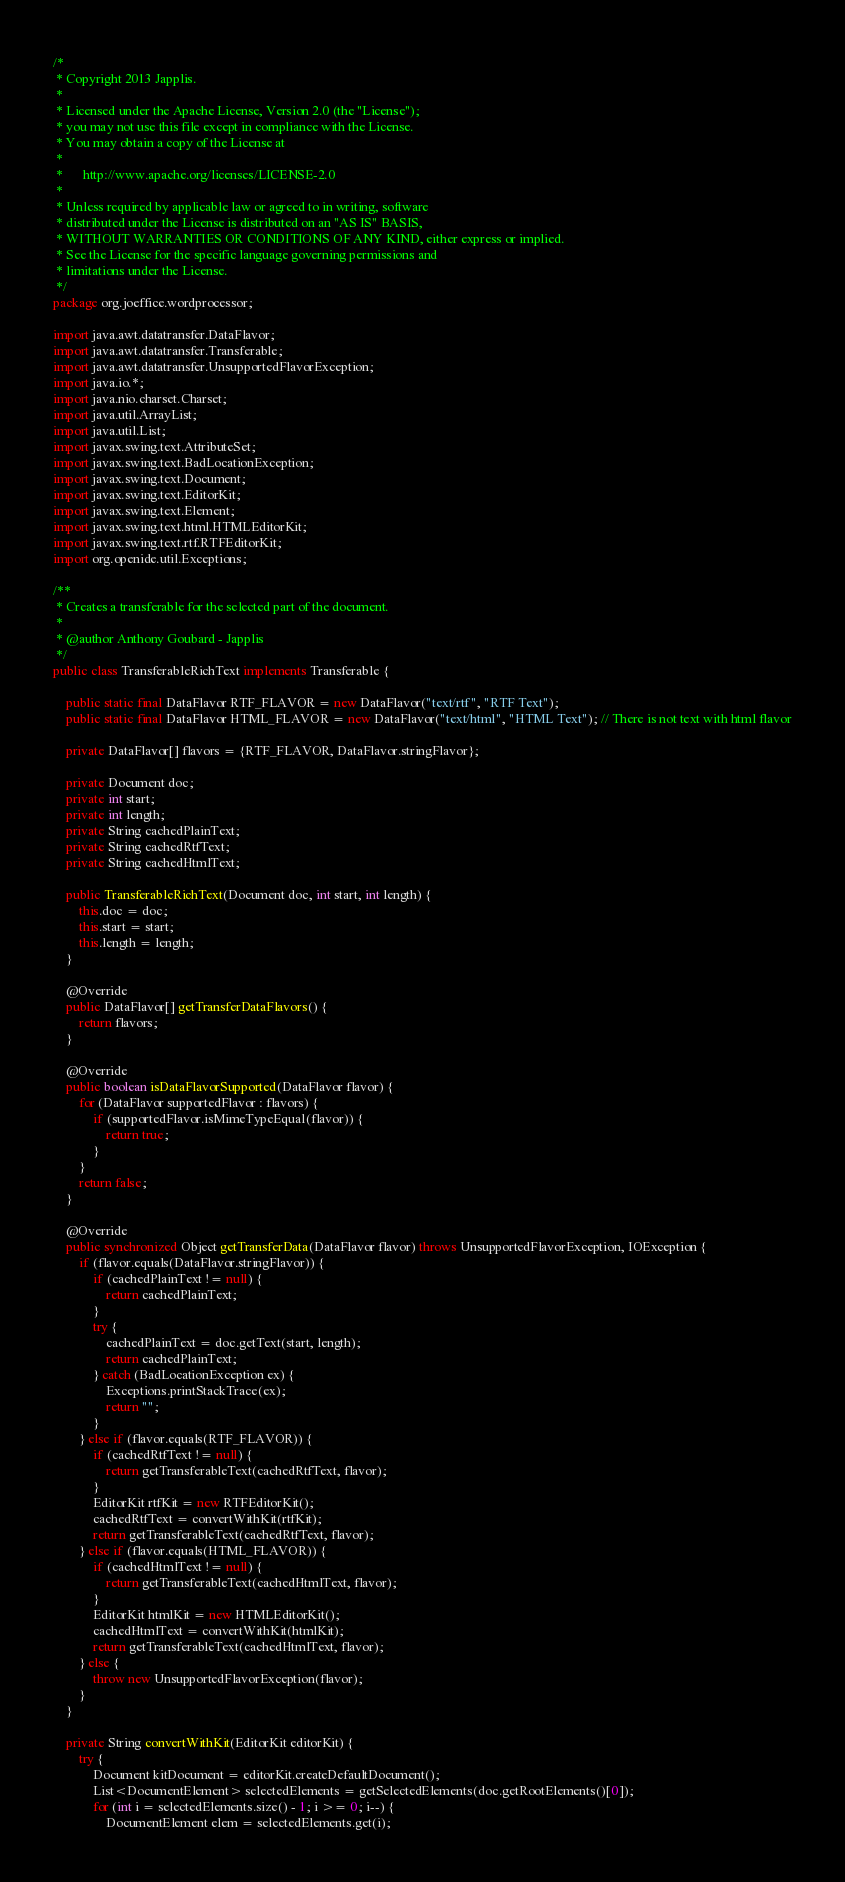Convert code to text. <code><loc_0><loc_0><loc_500><loc_500><_Java_>/*
 * Copyright 2013 Japplis.
 *
 * Licensed under the Apache License, Version 2.0 (the "License");
 * you may not use this file except in compliance with the License.
 * You may obtain a copy of the License at
 *
 *      http://www.apache.org/licenses/LICENSE-2.0
 *
 * Unless required by applicable law or agreed to in writing, software
 * distributed under the License is distributed on an "AS IS" BASIS,
 * WITHOUT WARRANTIES OR CONDITIONS OF ANY KIND, either express or implied.
 * See the License for the specific language governing permissions and
 * limitations under the License.
 */
package org.joeffice.wordprocessor;

import java.awt.datatransfer.DataFlavor;
import java.awt.datatransfer.Transferable;
import java.awt.datatransfer.UnsupportedFlavorException;
import java.io.*;
import java.nio.charset.Charset;
import java.util.ArrayList;
import java.util.List;
import javax.swing.text.AttributeSet;
import javax.swing.text.BadLocationException;
import javax.swing.text.Document;
import javax.swing.text.EditorKit;
import javax.swing.text.Element;
import javax.swing.text.html.HTMLEditorKit;
import javax.swing.text.rtf.RTFEditorKit;
import org.openide.util.Exceptions;

/**
 * Creates a transferable for the selected part of the document.
 *
 * @author Anthony Goubard - Japplis
 */
public class TransferableRichText implements Transferable {

    public static final DataFlavor RTF_FLAVOR = new DataFlavor("text/rtf", "RTF Text");
    public static final DataFlavor HTML_FLAVOR = new DataFlavor("text/html", "HTML Text"); // There is not text with html flavor

    private DataFlavor[] flavors = {RTF_FLAVOR, DataFlavor.stringFlavor};

    private Document doc;
    private int start;
    private int length;
    private String cachedPlainText;
    private String cachedRtfText;
    private String cachedHtmlText;

    public TransferableRichText(Document doc, int start, int length) {
        this.doc = doc;
        this.start = start;
        this.length = length;
    }

    @Override
    public DataFlavor[] getTransferDataFlavors() {
        return flavors;
    }

    @Override
    public boolean isDataFlavorSupported(DataFlavor flavor) {
        for (DataFlavor supportedFlavor : flavors) {
            if (supportedFlavor.isMimeTypeEqual(flavor)) {
                return true;
            }
        }
        return false;
    }

    @Override
    public synchronized Object getTransferData(DataFlavor flavor) throws UnsupportedFlavorException, IOException {
        if (flavor.equals(DataFlavor.stringFlavor)) {
            if (cachedPlainText != null) {
                return cachedPlainText;
            }
            try {
                cachedPlainText = doc.getText(start, length);
                return cachedPlainText;
            } catch (BadLocationException ex) {
                Exceptions.printStackTrace(ex);
                return "";
            }
        } else if (flavor.equals(RTF_FLAVOR)) {
            if (cachedRtfText != null) {
                return getTransferableText(cachedRtfText, flavor);
            }
            EditorKit rtfKit = new RTFEditorKit();
            cachedRtfText = convertWithKit(rtfKit);
            return getTransferableText(cachedRtfText, flavor);
        } else if (flavor.equals(HTML_FLAVOR)) {
            if (cachedHtmlText != null) {
                return getTransferableText(cachedHtmlText, flavor);
            }
            EditorKit htmlKit = new HTMLEditorKit();
            cachedHtmlText = convertWithKit(htmlKit);
            return getTransferableText(cachedHtmlText, flavor);
        } else {
            throw new UnsupportedFlavorException(flavor);
        }
    }

    private String convertWithKit(EditorKit editorKit) {
        try {
            Document kitDocument = editorKit.createDefaultDocument();
            List<DocumentElement> selectedElements = getSelectedElements(doc.getRootElements()[0]);
            for (int i = selectedElements.size() - 1; i >= 0; i--) {
                DocumentElement elem = selectedElements.get(i);</code> 